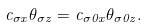Convert formula to latex. <formula><loc_0><loc_0><loc_500><loc_500>c _ { \sigma x } \theta _ { \sigma z } = c _ { \sigma 0 x } \theta _ { \sigma 0 z } .</formula> 